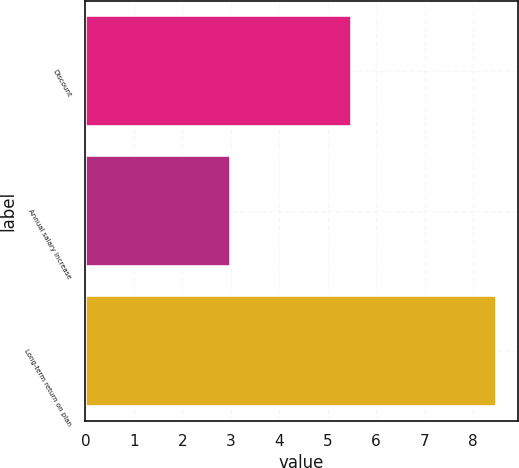<chart> <loc_0><loc_0><loc_500><loc_500><bar_chart><fcel>Discount<fcel>Annual salary increase<fcel>Long-term return on plan<nl><fcel>5.5<fcel>3<fcel>8.5<nl></chart> 